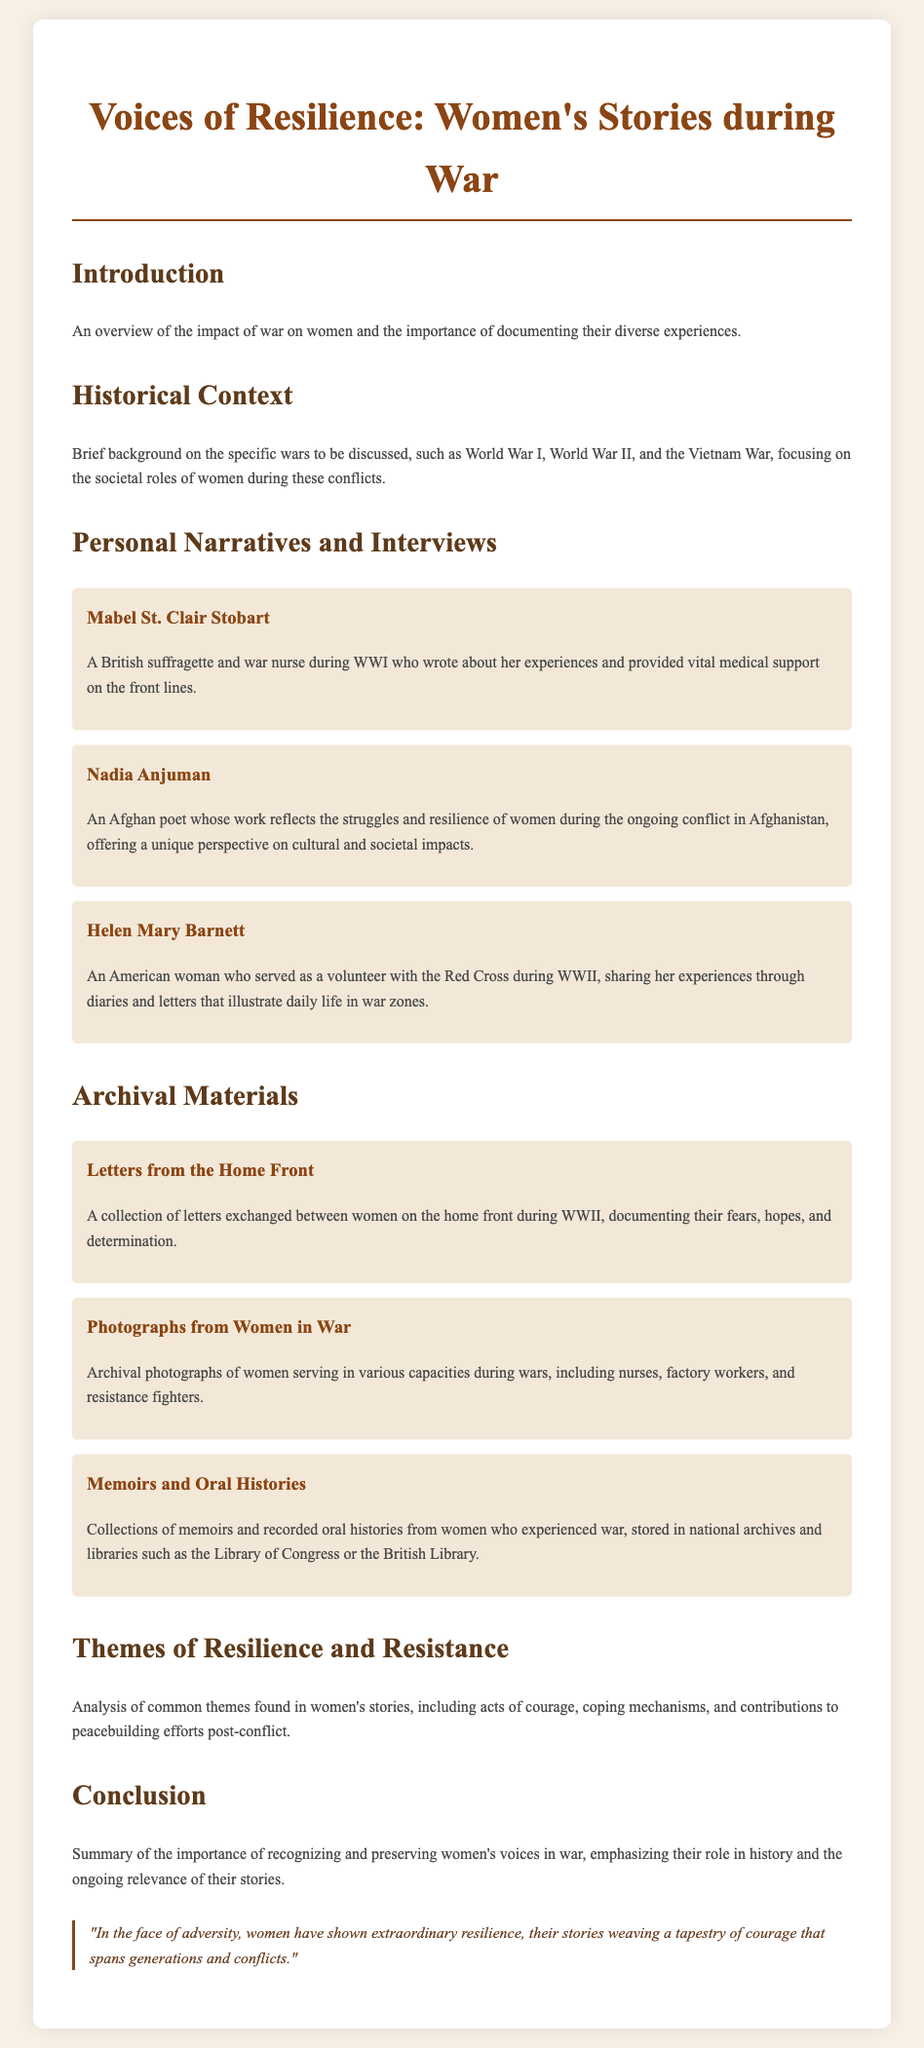What is the title of the chapter? The title of the chapter is displayed prominently at the beginning of the document.
Answer: Voices of Resilience: Women's Stories during War Who is Mabel St. Clair Stobart? Mabel St. Clair Stobart is mentioned as a British suffragette and war nurse during WWI.
Answer: A British suffragette and war nurse during WWI What type of materials are included in the Archival Materials section? The Archival Materials section lists various collections related to women's experiences during war.
Answer: Letters, photographs, memoirs How many interview subjects are listed in the document? The document includes a section with several interview subjects providing personal narratives.
Answer: Three What war is Nadia Anjuman associated with? Nadia Anjuman's work reflects the struggles of women during an ongoing conflict.
Answer: Afghanistan What is one common theme analyzed in women's stories? The document mentions themes found in women's stories, with a focus on their resilience during war.
Answer: Acts of courage Which women's roles are highlighted in the photographs from the Archival Materials? The photograph collection showcases women serving in multiple roles during conflict, as described in the document.
Answer: Nurses, factory workers, resistance fighters What is the conclusion of the chapter about? The conclusion emphasizes the importance of preserving women's voices in the context of war.
Answer: Recognizing and preserving women's voices in war 